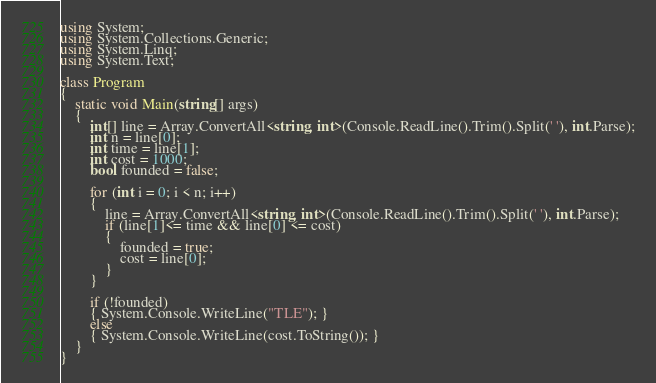Convert code to text. <code><loc_0><loc_0><loc_500><loc_500><_C#_>using System;
using System.Collections.Generic;
using System.Linq;
using System.Text;

class Program
{
    static void Main(string[] args)
    {
        int[] line = Array.ConvertAll<string, int>(Console.ReadLine().Trim().Split(' '), int.Parse);
        int n = line[0];
        int time = line[1];
        int cost = 1000;
        bool founded = false;

        for (int i = 0; i < n; i++)
        {
            line = Array.ConvertAll<string, int>(Console.ReadLine().Trim().Split(' '), int.Parse);
            if (line[1]<= time && line[0] <= cost)
            {
                founded = true;
                cost = line[0]; 
            }
        }

        if (!founded)
        { System.Console.WriteLine("TLE"); }
        else
        { System.Console.WriteLine(cost.ToString()); }
    }
}
</code> 